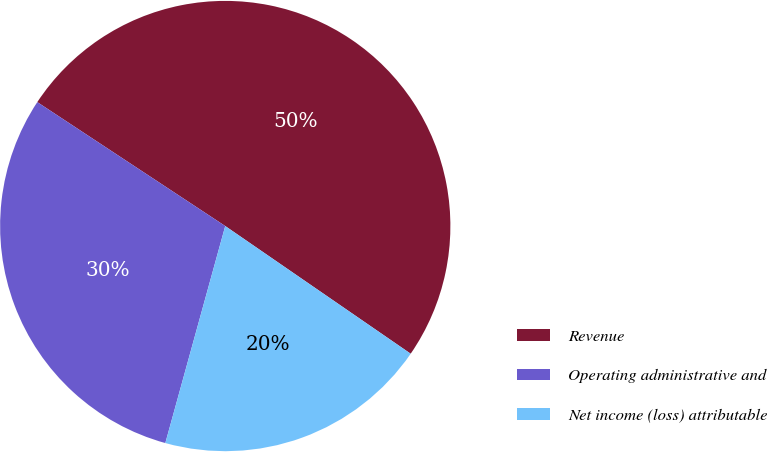Convert chart to OTSL. <chart><loc_0><loc_0><loc_500><loc_500><pie_chart><fcel>Revenue<fcel>Operating administrative and<fcel>Net income (loss) attributable<nl><fcel>50.32%<fcel>29.99%<fcel>19.69%<nl></chart> 